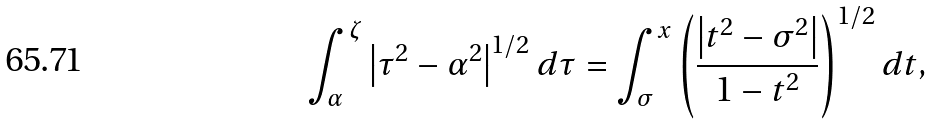<formula> <loc_0><loc_0><loc_500><loc_500>\int _ { \alpha } ^ { \zeta } { \left | { \tau ^ { 2 } - \alpha ^ { 2 } } \right | ^ { 1 / 2 } d \tau } = \int _ { \sigma } ^ { x } { \left ( { \frac { \left | { t ^ { 2 } - \sigma ^ { 2 } } \right | } { 1 - t ^ { 2 } } } \right ) ^ { 1 / 2 } d t } ,</formula> 